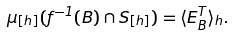Convert formula to latex. <formula><loc_0><loc_0><loc_500><loc_500>\mu _ { [ h ] } ( f ^ { - 1 } ( B ) \cap S _ { [ h ] } ) = \langle E _ { B } ^ { T } \rangle _ { h } .</formula> 